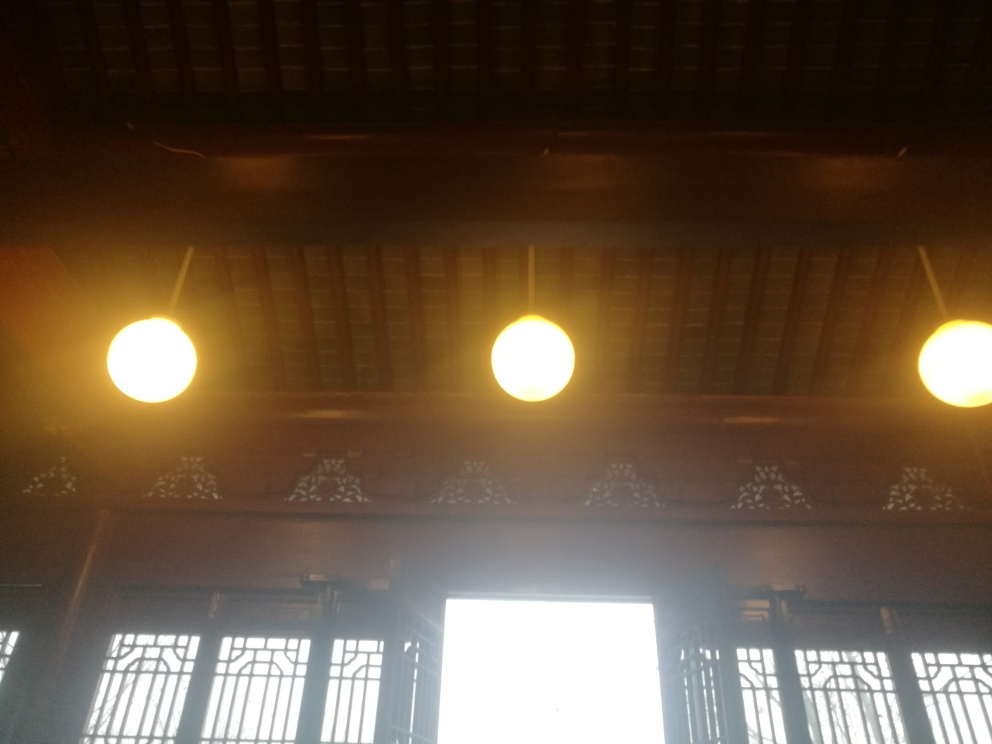What could be improved in this image? The overexposed areas, particularly the bright window, could benefit from brightness adjustment to reveal more detail. Moreover, this would help to balance the exposure across the image, making the interior elements more visible and enhancing the overall photo quality. 